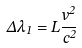<formula> <loc_0><loc_0><loc_500><loc_500>\Delta { \lambda } _ { 1 } = { L } { \frac { v ^ { 2 } } { c ^ { 2 } } }</formula> 